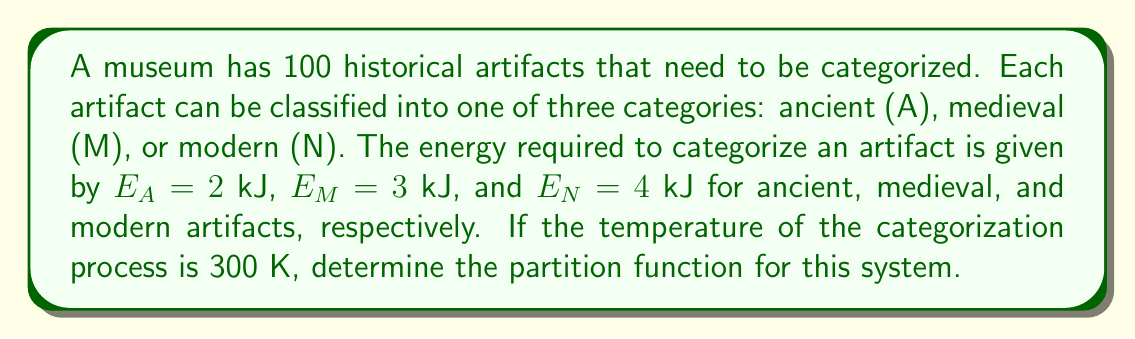Show me your answer to this math problem. To solve this problem, we'll follow these steps:

1) The partition function Z for a system with discrete energy levels is given by:

   $$Z = \sum_i g_i e^{-\beta E_i}$$

   where $g_i$ is the degeneracy of energy level $E_i$, and $\beta = \frac{1}{k_B T}$.

2) In this case, we have three energy levels corresponding to the three categories. The degeneracy for each level is 100, as any of the 100 artifacts could be in any category.

3) We need to calculate $\beta$:
   $$\beta = \frac{1}{k_B T} = \frac{1}{(1.38 \times 10^{-23} \text{ J/K})(300 \text{ K})} = 2.42 \times 10^{20} \text{ J}^{-1}$$

4) Now, we can calculate each term of the partition function:

   For ancient artifacts: $100 e^{-\beta E_A} = 100 e^{-(2.42 \times 10^{20})(2 \times 10^3)}$
   
   For medieval artifacts: $100 e^{-\beta E_M} = 100 e^{-(2.42 \times 10^{20})(3 \times 10^3)}$
   
   For modern artifacts: $100 e^{-\beta E_N} = 100 e^{-(2.42 \times 10^{20})(4 \times 10^3)}$

5) The partition function is the sum of these terms:

   $$Z = 100(e^{-4.84 \times 10^{23}} + e^{-7.26 \times 10^{23}} + e^{-9.68 \times 10^{23}})$$

6) Simplifying:

   $$Z = 100(1 + e^{-2.42 \times 10^{23}} + e^{-4.84 \times 10^{23}})$$

This is the final form of the partition function for this system.
Answer: $$Z = 100(1 + e^{-2.42 \times 10^{23}} + e^{-4.84 \times 10^{23}})$$ 